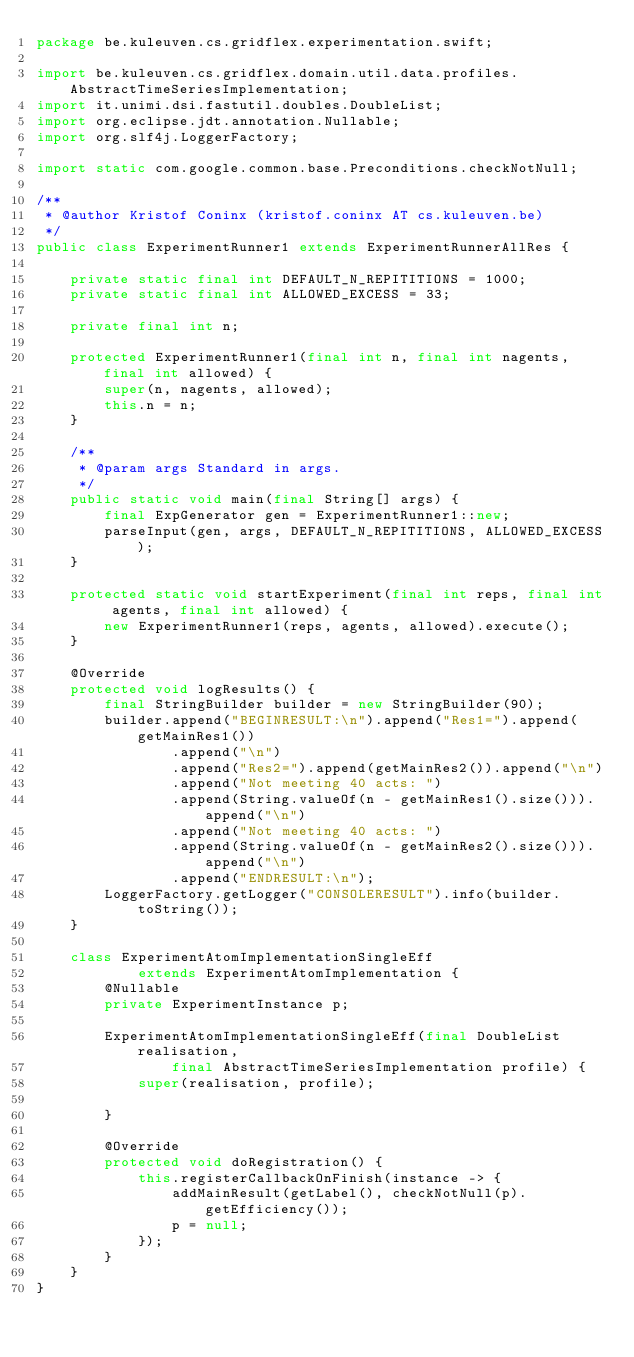<code> <loc_0><loc_0><loc_500><loc_500><_Java_>package be.kuleuven.cs.gridflex.experimentation.swift;

import be.kuleuven.cs.gridflex.domain.util.data.profiles.AbstractTimeSeriesImplementation;
import it.unimi.dsi.fastutil.doubles.DoubleList;
import org.eclipse.jdt.annotation.Nullable;
import org.slf4j.LoggerFactory;

import static com.google.common.base.Preconditions.checkNotNull;

/**
 * @author Kristof Coninx (kristof.coninx AT cs.kuleuven.be)
 */
public class ExperimentRunner1 extends ExperimentRunnerAllRes {

    private static final int DEFAULT_N_REPITITIONS = 1000;
    private static final int ALLOWED_EXCESS = 33;

    private final int n;

    protected ExperimentRunner1(final int n, final int nagents, final int allowed) {
        super(n, nagents, allowed);
        this.n = n;
    }

    /**
     * @param args Standard in args.
     */
    public static void main(final String[] args) {
        final ExpGenerator gen = ExperimentRunner1::new;
        parseInput(gen, args, DEFAULT_N_REPITITIONS, ALLOWED_EXCESS);
    }

    protected static void startExperiment(final int reps, final int agents, final int allowed) {
        new ExperimentRunner1(reps, agents, allowed).execute();
    }

    @Override
    protected void logResults() {
        final StringBuilder builder = new StringBuilder(90);
        builder.append("BEGINRESULT:\n").append("Res1=").append(getMainRes1())
                .append("\n")
                .append("Res2=").append(getMainRes2()).append("\n")
                .append("Not meeting 40 acts: ")
                .append(String.valueOf(n - getMainRes1().size())).append("\n")
                .append("Not meeting 40 acts: ")
                .append(String.valueOf(n - getMainRes2().size())).append("\n")
                .append("ENDRESULT:\n");
        LoggerFactory.getLogger("CONSOLERESULT").info(builder.toString());
    }

    class ExperimentAtomImplementationSingleEff
            extends ExperimentAtomImplementation {
        @Nullable
        private ExperimentInstance p;

        ExperimentAtomImplementationSingleEff(final DoubleList realisation,
                final AbstractTimeSeriesImplementation profile) {
            super(realisation, profile);

        }

        @Override
        protected void doRegistration() {
            this.registerCallbackOnFinish(instance -> {
                addMainResult(getLabel(), checkNotNull(p).getEfficiency());
                p = null;
            });
        }
    }
}
</code> 